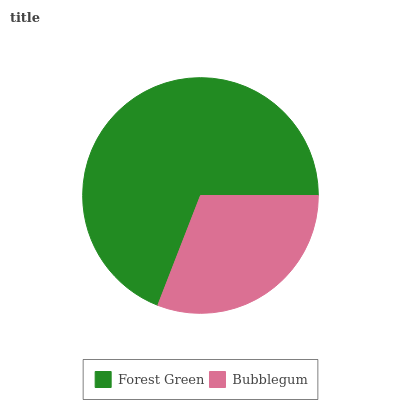Is Bubblegum the minimum?
Answer yes or no. Yes. Is Forest Green the maximum?
Answer yes or no. Yes. Is Bubblegum the maximum?
Answer yes or no. No. Is Forest Green greater than Bubblegum?
Answer yes or no. Yes. Is Bubblegum less than Forest Green?
Answer yes or no. Yes. Is Bubblegum greater than Forest Green?
Answer yes or no. No. Is Forest Green less than Bubblegum?
Answer yes or no. No. Is Forest Green the high median?
Answer yes or no. Yes. Is Bubblegum the low median?
Answer yes or no. Yes. Is Bubblegum the high median?
Answer yes or no. No. Is Forest Green the low median?
Answer yes or no. No. 